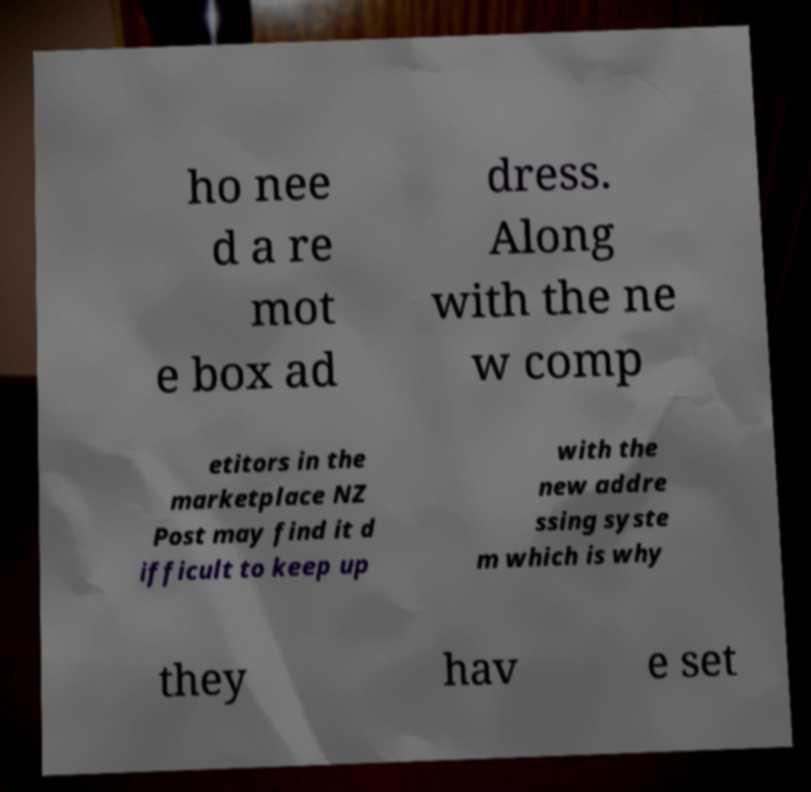Could you assist in decoding the text presented in this image and type it out clearly? ho nee d a re mot e box ad dress. Along with the ne w comp etitors in the marketplace NZ Post may find it d ifficult to keep up with the new addre ssing syste m which is why they hav e set 